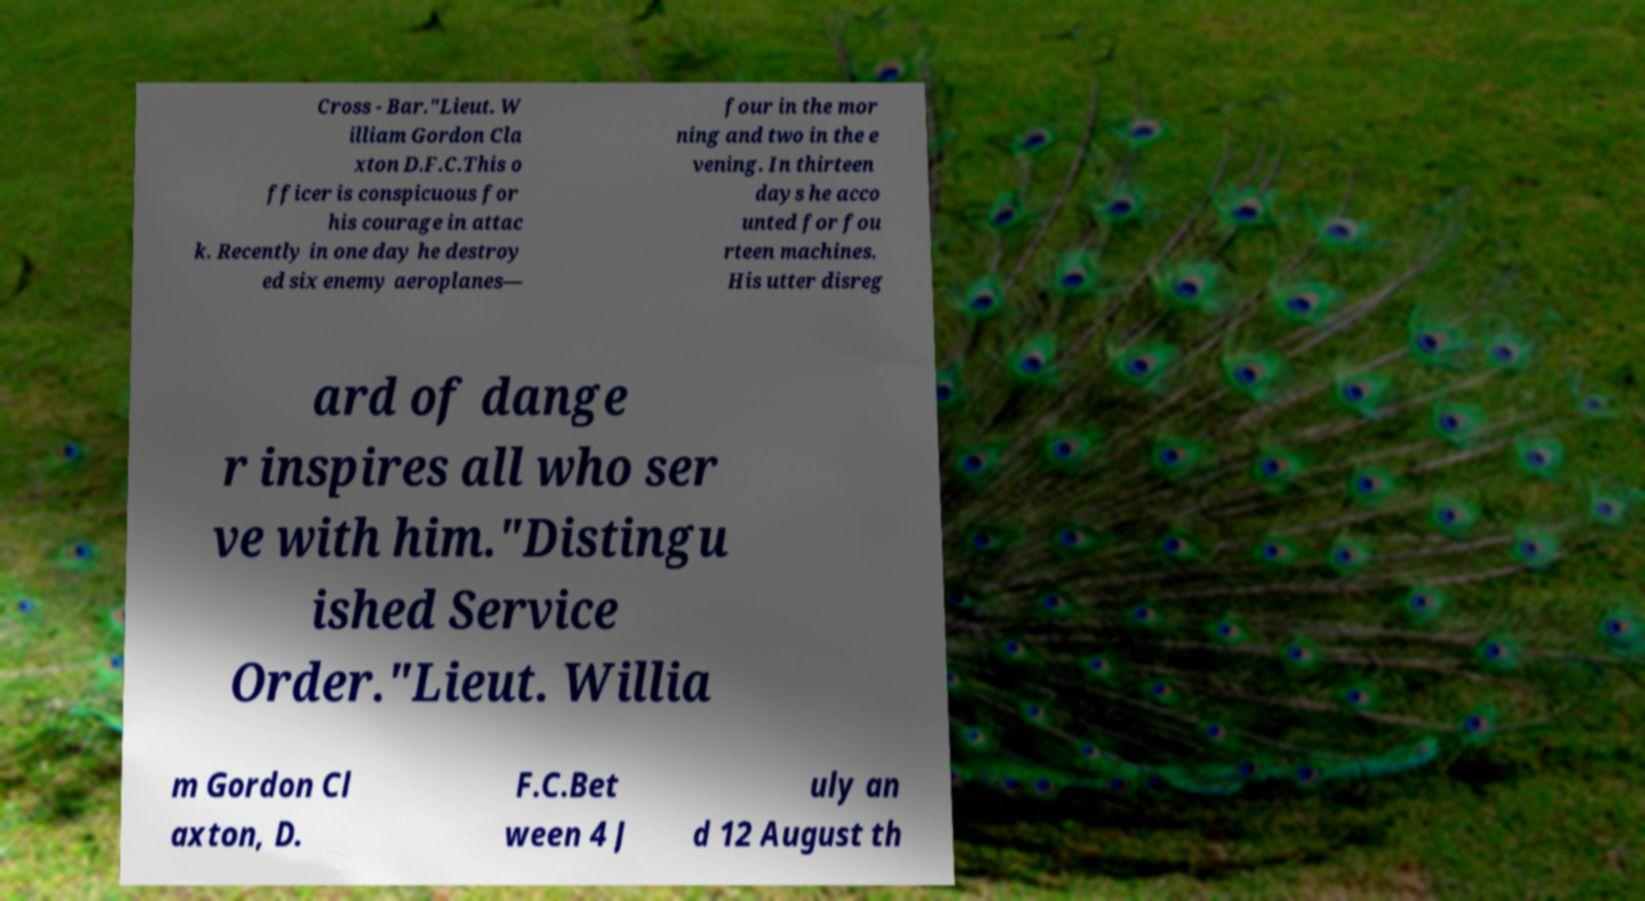Can you read and provide the text displayed in the image?This photo seems to have some interesting text. Can you extract and type it out for me? Cross - Bar."Lieut. W illiam Gordon Cla xton D.F.C.This o fficer is conspicuous for his courage in attac k. Recently in one day he destroy ed six enemy aeroplanes— four in the mor ning and two in the e vening. In thirteen days he acco unted for fou rteen machines. His utter disreg ard of dange r inspires all who ser ve with him."Distingu ished Service Order."Lieut. Willia m Gordon Cl axton, D. F.C.Bet ween 4 J uly an d 12 August th 